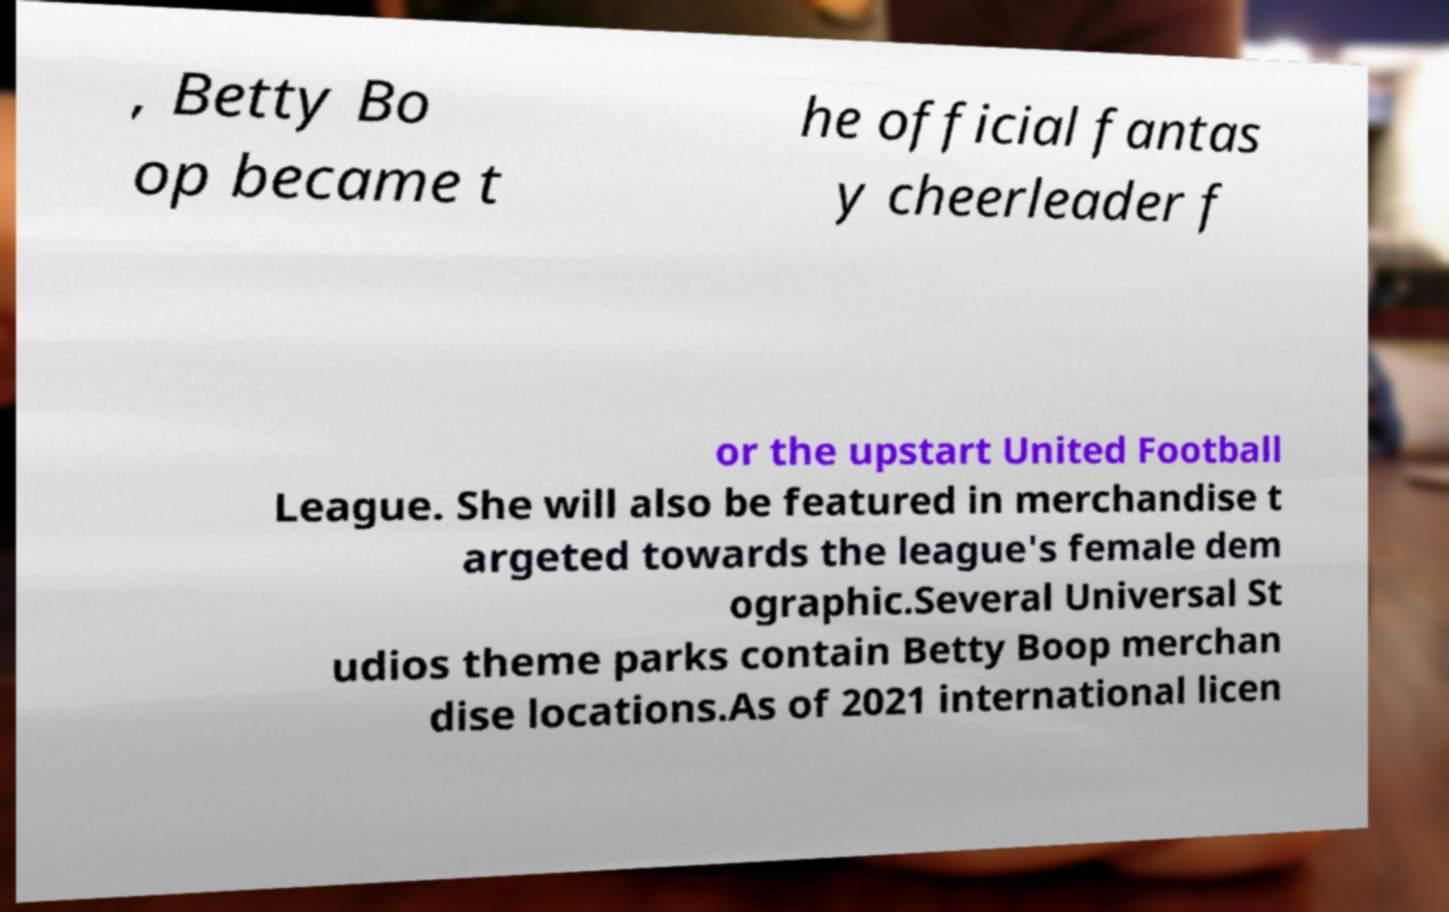For documentation purposes, I need the text within this image transcribed. Could you provide that? , Betty Bo op became t he official fantas y cheerleader f or the upstart United Football League. She will also be featured in merchandise t argeted towards the league's female dem ographic.Several Universal St udios theme parks contain Betty Boop merchan dise locations.As of 2021 international licen 